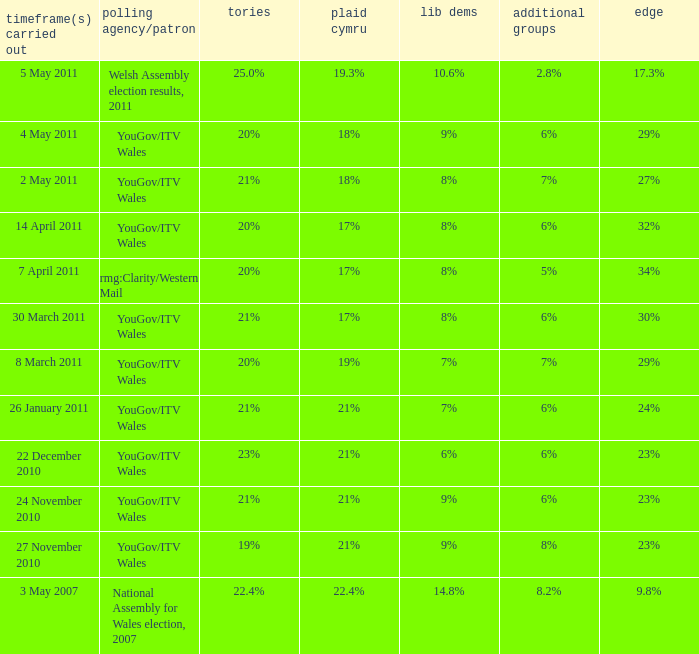I want the plaid cymru for 4 may 2011 18%. 